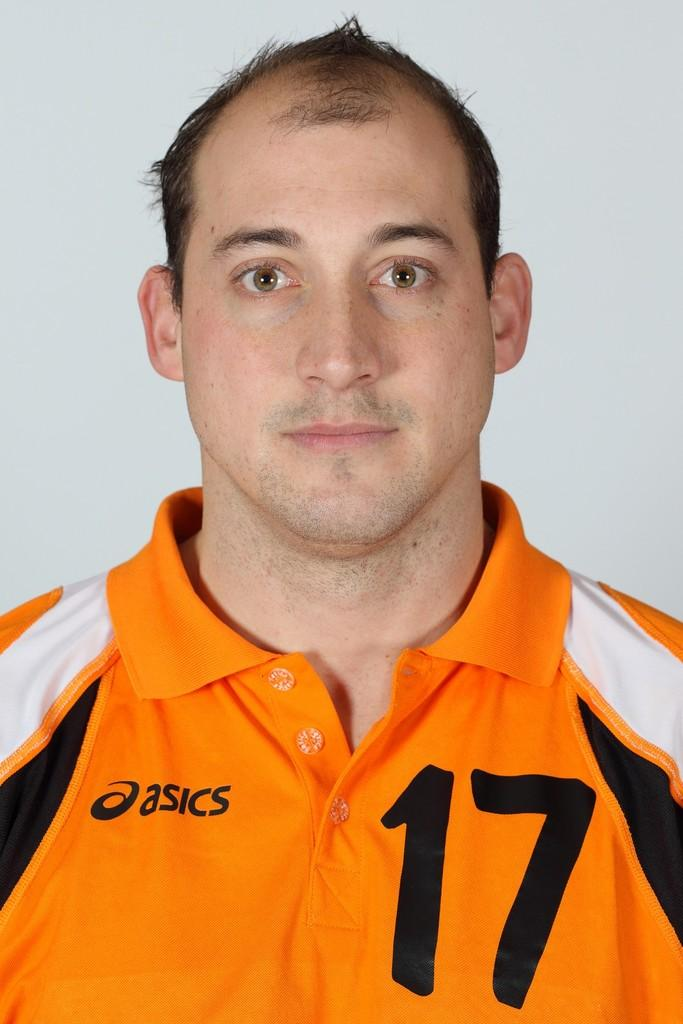<image>
Render a clear and concise summary of the photo. A man wearing an Asics brand shirt with the number seventeen on the front. 